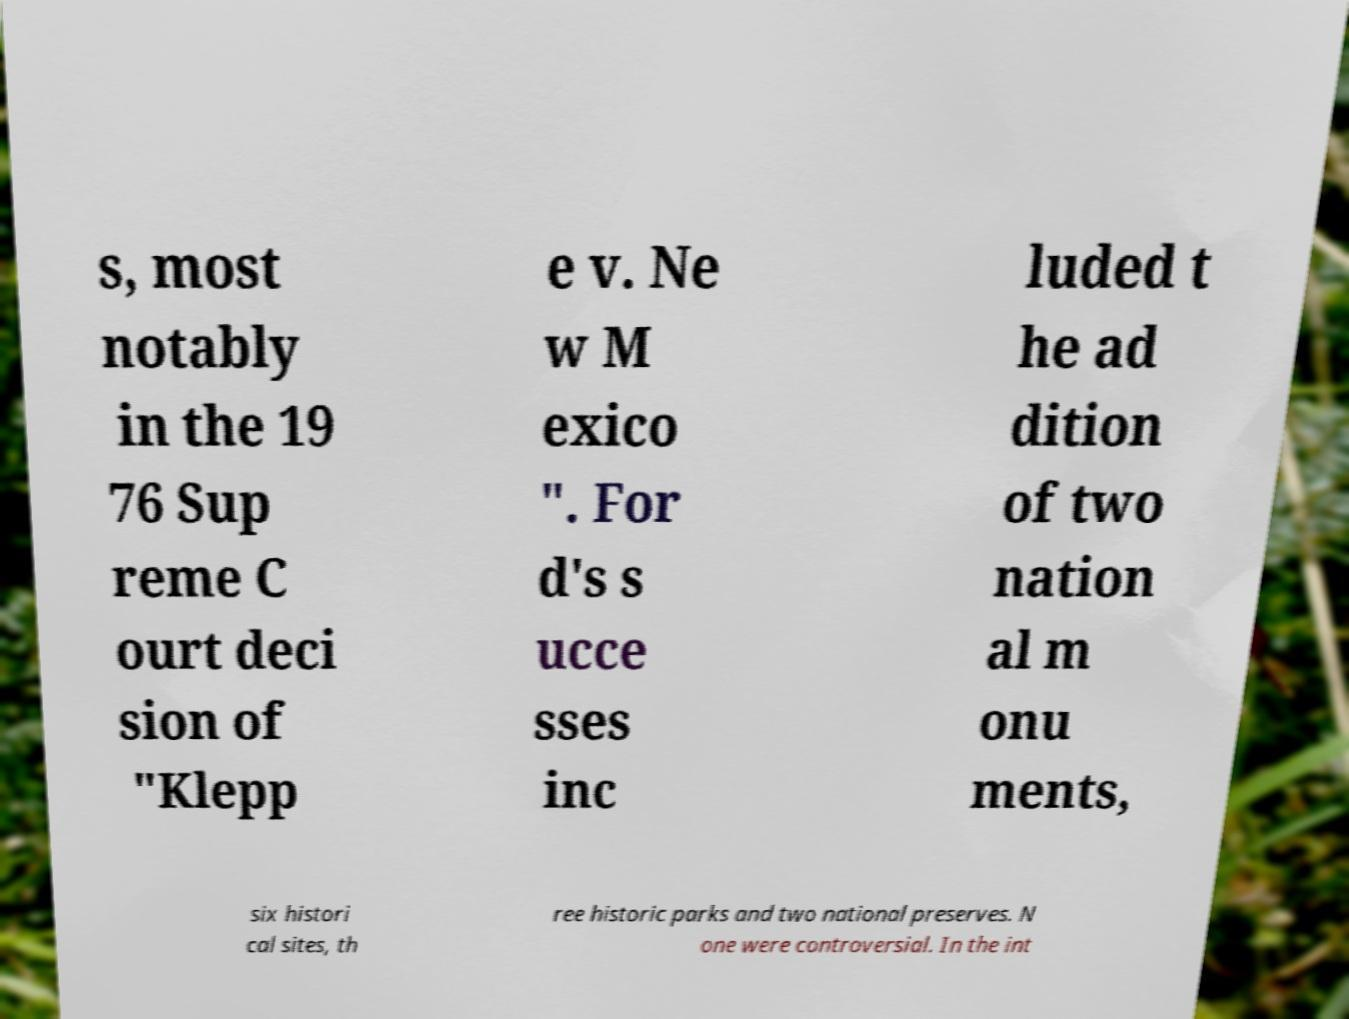What messages or text are displayed in this image? I need them in a readable, typed format. s, most notably in the 19 76 Sup reme C ourt deci sion of "Klepp e v. Ne w M exico ". For d's s ucce sses inc luded t he ad dition of two nation al m onu ments, six histori cal sites, th ree historic parks and two national preserves. N one were controversial. In the int 